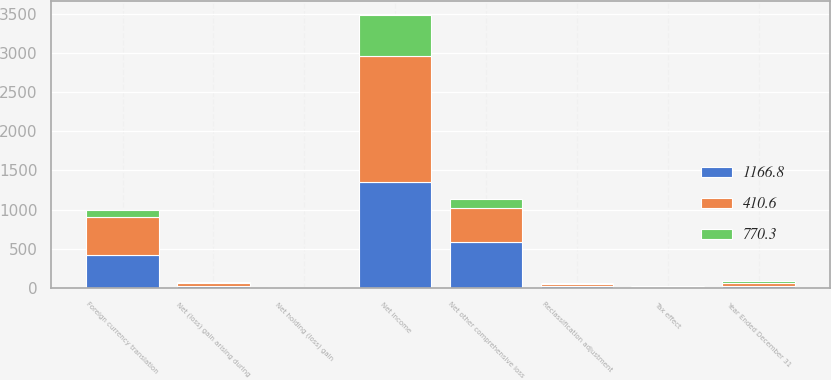<chart> <loc_0><loc_0><loc_500><loc_500><stacked_bar_chart><ecel><fcel>Year Ended December 31<fcel>Net income<fcel>Net (loss) gain arising during<fcel>Tax effect<fcel>Reclassification adjustment<fcel>Net holding (loss) gain<fcel>Foreign currency translation<fcel>Net other comprehensive loss<nl><fcel>770.3<fcel>29.3<fcel>521.7<fcel>6.5<fcel>6.7<fcel>10.8<fcel>0.1<fcel>87.1<fcel>111.1<nl><fcel>410.6<fcel>29.3<fcel>1604<fcel>38.7<fcel>10.8<fcel>29.3<fcel>2.3<fcel>483.8<fcel>437.2<nl><fcel>1166.8<fcel>29.3<fcel>1358.8<fcel>26.1<fcel>6.1<fcel>23.5<fcel>5.5<fcel>422.8<fcel>588.5<nl></chart> 